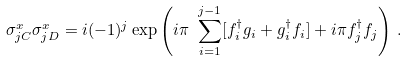Convert formula to latex. <formula><loc_0><loc_0><loc_500><loc_500>\sigma _ { j C } ^ { x } \sigma _ { j D } ^ { x } = { i } ( - 1 ) ^ { j } \exp \left ( i \pi \ \sum _ { i = 1 } ^ { j - 1 } [ f ^ { \dagger } _ { i } g _ { i } + g ^ { \dagger } _ { i } f _ { i } ] + i \pi f ^ { \dagger } _ { j } f _ { j } \right ) \, .</formula> 